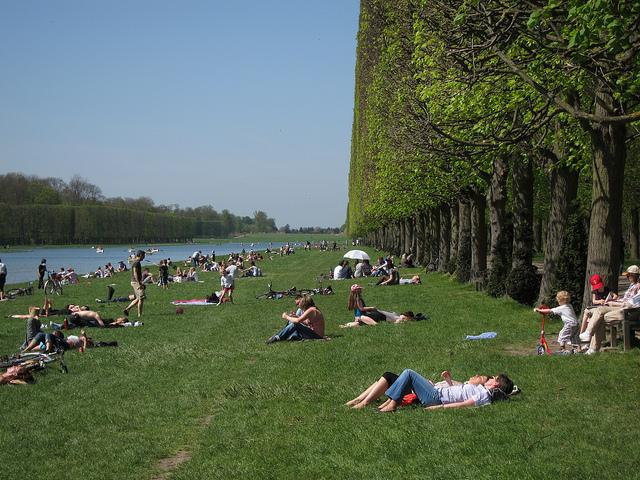Why are these people laying here? relaxing 